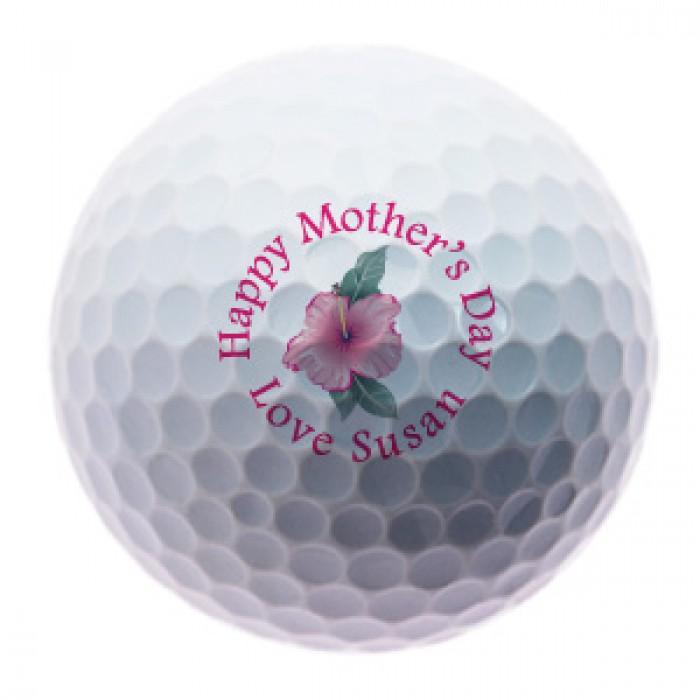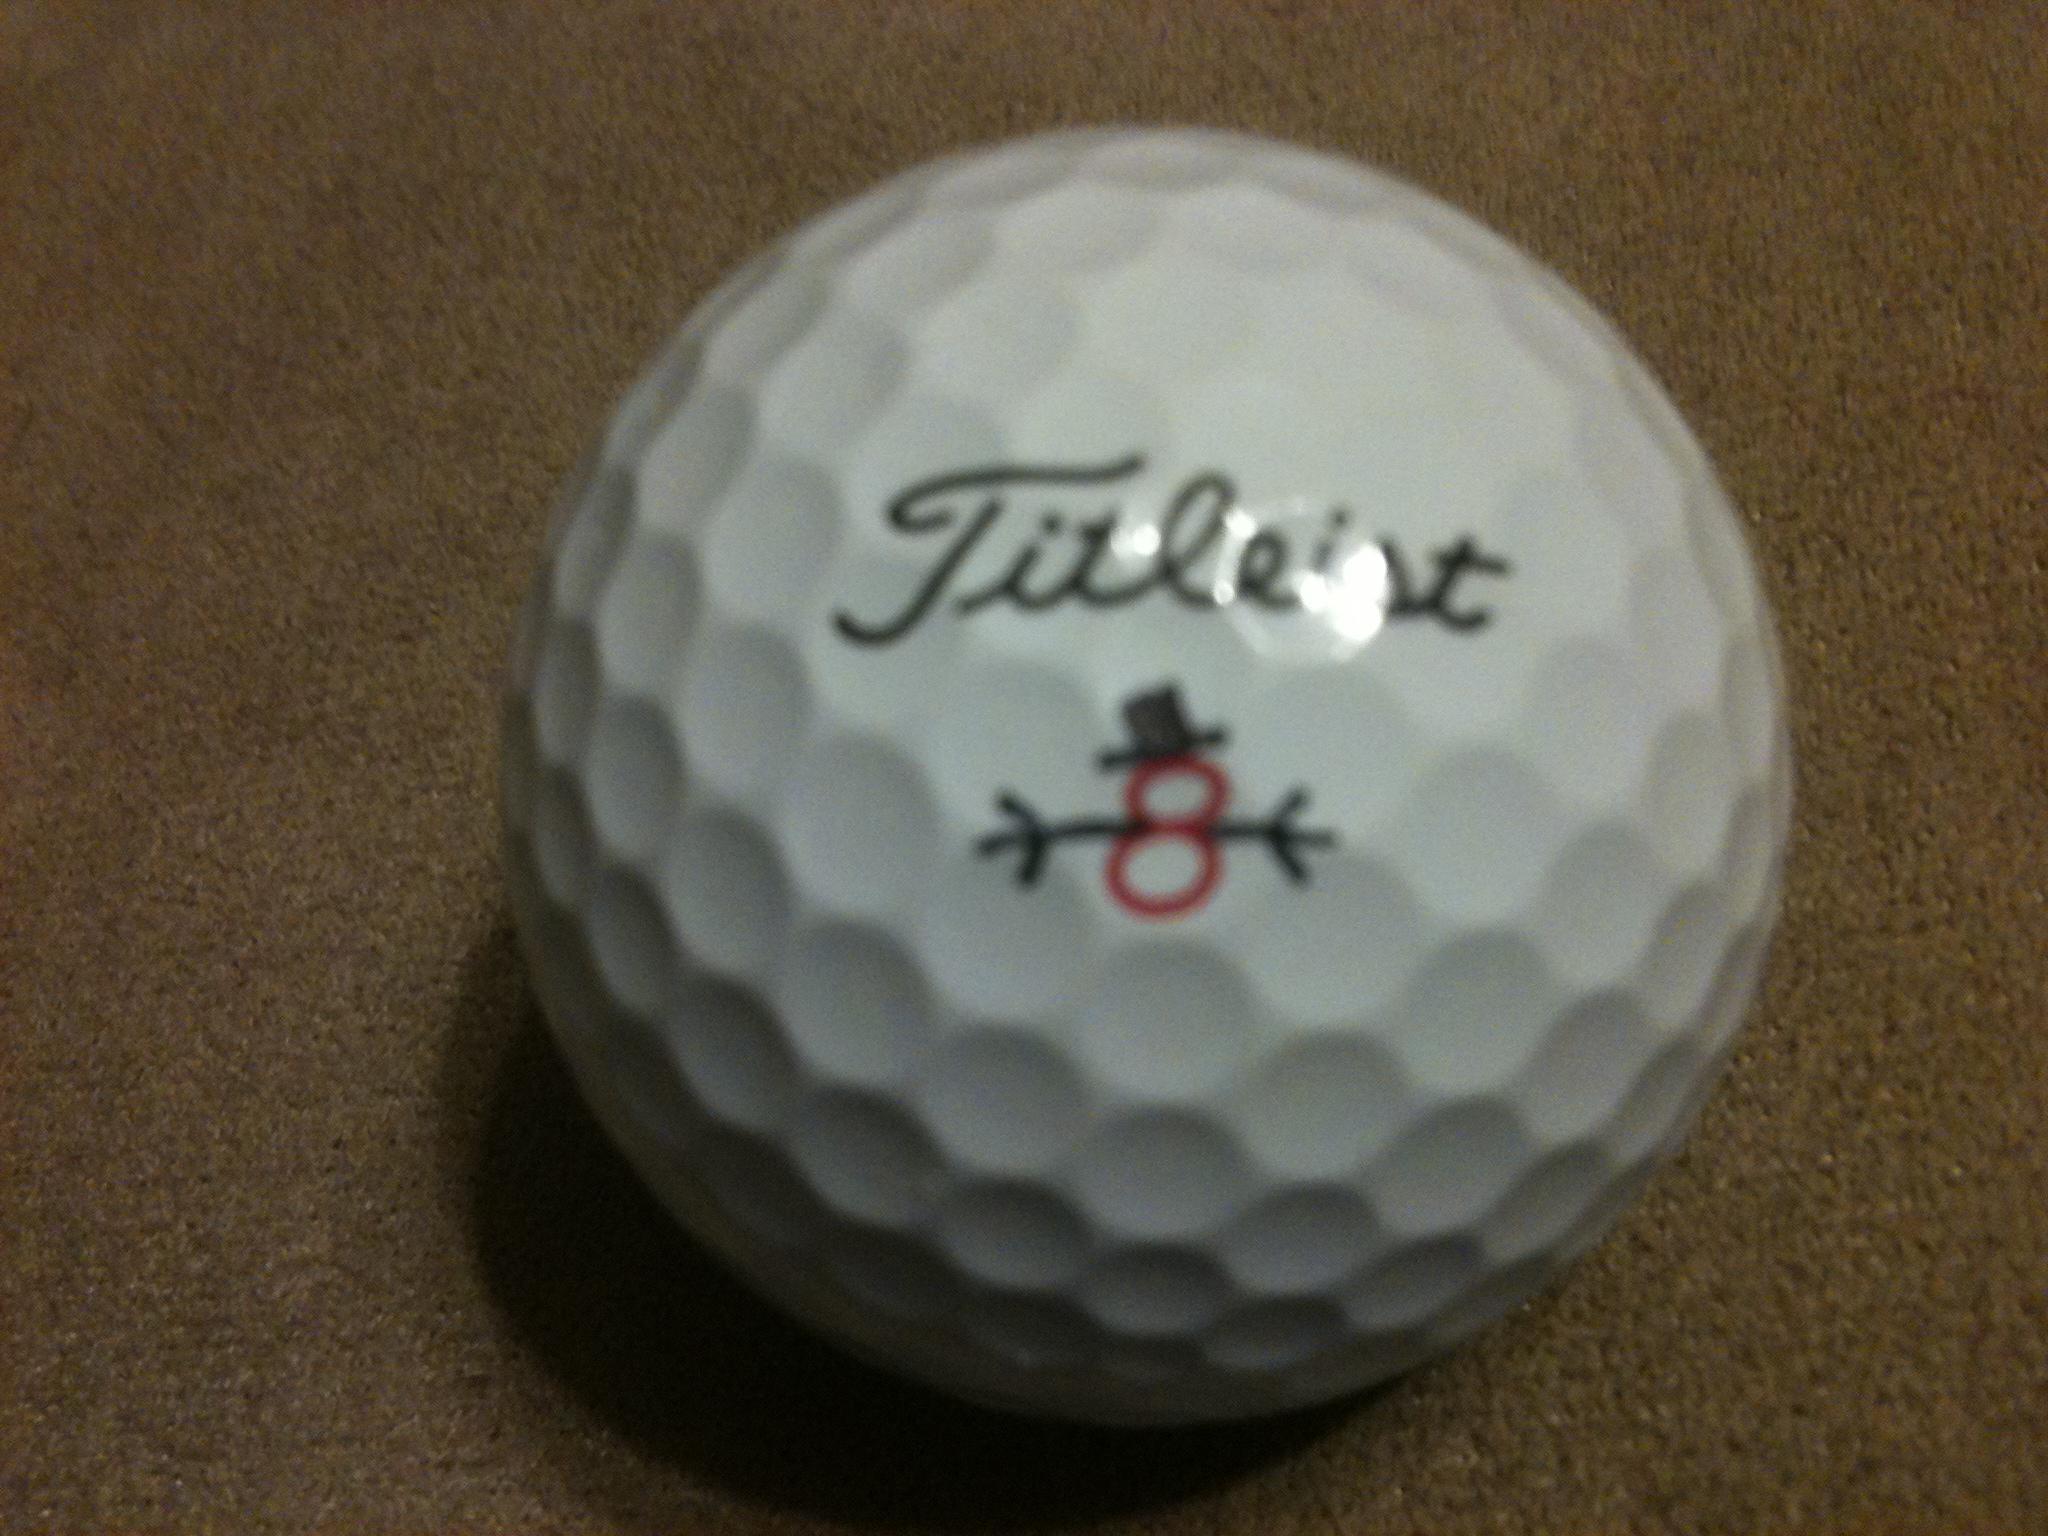The first image is the image on the left, the second image is the image on the right. Evaluate the accuracy of this statement regarding the images: "The left image is a golf ball with a flower on it.". Is it true? Answer yes or no. Yes. The first image is the image on the left, the second image is the image on the right. For the images displayed, is the sentence "The left and right image contains the same number of playable golf clubs." factually correct? Answer yes or no. Yes. 